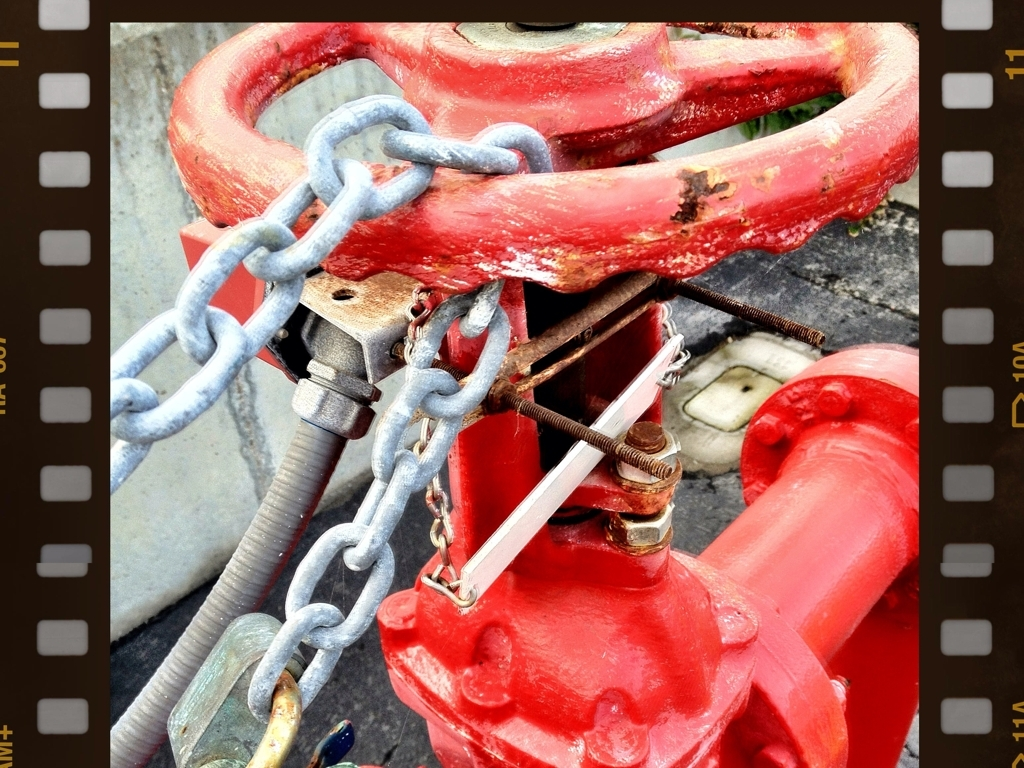What can you tell me about the condition of the fire hydrant given its appearance? The observable scratches and rust on the fire hydrant suggest that it has been exposed to the elements for a significant period. Additionally, the presence of wear and chipped paint indicates that the hydrant has likely been used multiple times or has been impacted by vehicles or street activities. Despite these signs of aging, it appears to still be sturdy and potentially operational, but might require maintenance to ensure its reliability. 